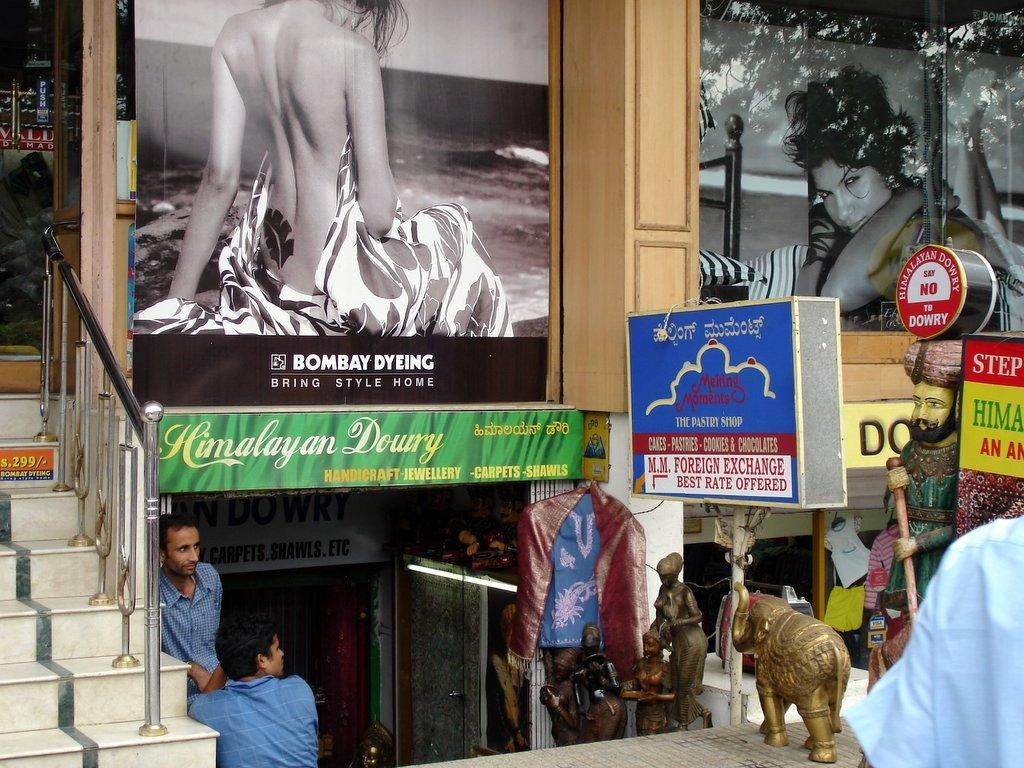How many people can be seen in the image? There are people in the image, but the exact number is not specified. What objects are present in the image that resemble flat surfaces with writing or images on them? There are boards and posters in the image. What type of clothing items can be seen in the image? There are clothes in the image. What type of artwork is visible in the image? There are sculptures in the image. What type of structure is present in the image? There is a building in the image. What type of construction material is visible in the image? There are iron rods in the image. What type of illumination is present in the image? There is light in the image. What other items are present in the image that are not specified in the facts? There are other items in the image. What type of natural elements can be seen in the image through reflections? There is a reflection of trees and the sky in the image. Absurd Question/Answer: How many owls can be seen in the image? There are no owls present in the image. What type of books can be seen in the image? There is no mention of books in the image. Can you tell me how many geese are depicted on the poster? There are no geese depicted on the poster; it features a picture of a pot. What type of creature is shown interacting with the pot on the poster? There is no creature shown interacting with the pot on the poster; only the pot and letters are present. --- Facts: 1. There is a house on the left side of the image. 2. There appears to be a tower in the middle of the image. 3. There are trees on the right side of the image. 4. The sky is visible at the top of the image. Absurd Topics: cannon, zebra, front Conversation: What structure is located on the left side of the image? There is a house on the left side of the image. What can be seen in the middle of the image? There appears to be a tower in the middle of the image. What type of vegetation is on the right side of the image? There are trees on the right side of the image. What is visible at the top of the image? The sky is visible at the top of the image. Reasoning: Let's think step by step in order to produce the conversation. We start 